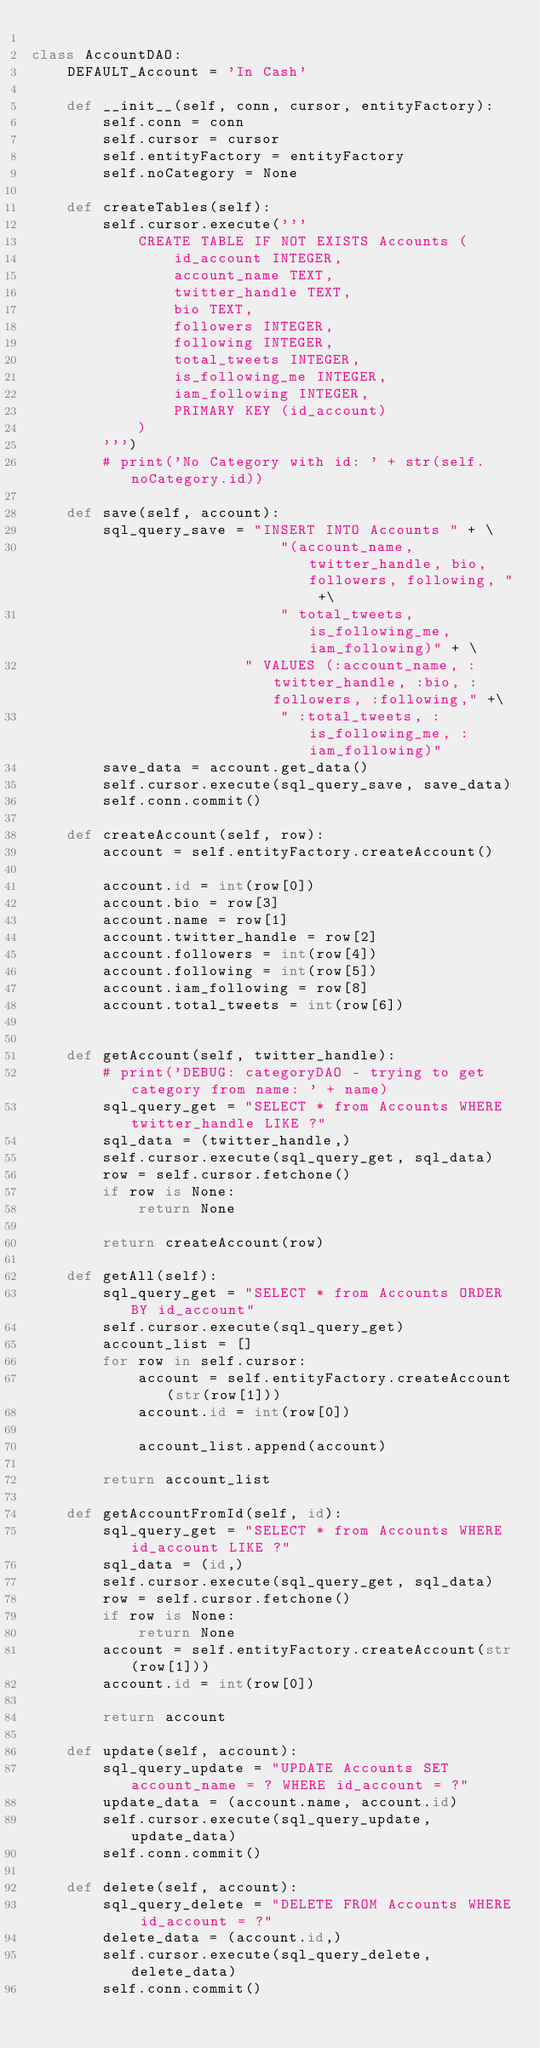<code> <loc_0><loc_0><loc_500><loc_500><_Python_>
class AccountDAO:
    DEFAULT_Account = 'In Cash'

    def __init__(self, conn, cursor, entityFactory):
        self.conn = conn
        self.cursor = cursor
        self.entityFactory = entityFactory
        self.noCategory = None

    def createTables(self):
        self.cursor.execute('''
            CREATE TABLE IF NOT EXISTS Accounts (
                id_account INTEGER,
                account_name TEXT,
                twitter_handle TEXT,
                bio TEXT,
                followers INTEGER,
                following INTEGER,
                total_tweets INTEGER,
                is_following_me INTEGER,
                iam_following INTEGER,
                PRIMARY KEY (id_account)
            )
        ''')
        # print('No Category with id: ' + str(self.noCategory.id))

    def save(self, account):
        sql_query_save = "INSERT INTO Accounts " + \
                            "(account_name, twitter_handle, bio, followers, following, " +\
                            " total_tweets, is_following_me, iam_following)" + \
                        " VALUES (:account_name, :twitter_handle, :bio, :followers, :following," +\
                            " :total_tweets, :is_following_me, :iam_following)"
        save_data = account.get_data()
        self.cursor.execute(sql_query_save, save_data)
        self.conn.commit()

    def createAccount(self, row):
        account = self.entityFactory.createAccount()

        account.id = int(row[0])
        account.bio = row[3]
        account.name = row[1]
        account.twitter_handle = row[2]
        account.followers = int(row[4])
        account.following = int(row[5])
        account.iam_following = row[8]
        account.total_tweets = int(row[6])


    def getAccount(self, twitter_handle):
        # print('DEBUG: categoryDAO - trying to get category from name: ' + name)
        sql_query_get = "SELECT * from Accounts WHERE twitter_handle LIKE ?"
        sql_data = (twitter_handle,)
        self.cursor.execute(sql_query_get, sql_data)
        row = self.cursor.fetchone()
        if row is None:
            return None
        
        return createAccount(row)

    def getAll(self):
        sql_query_get = "SELECT * from Accounts ORDER BY id_account"
        self.cursor.execute(sql_query_get)
        account_list = []
        for row in self.cursor:
            account = self.entityFactory.createAccount(str(row[1]))
            account.id = int(row[0])

            account_list.append(account)

        return account_list

    def getAccountFromId(self, id):
        sql_query_get = "SELECT * from Accounts WHERE id_account LIKE ?"
        sql_data = (id,)
        self.cursor.execute(sql_query_get, sql_data)
        row = self.cursor.fetchone()
        if row is None:
            return None
        account = self.entityFactory.createAccount(str(row[1]))
        account.id = int(row[0])

        return account

    def update(self, account):
        sql_query_update = "UPDATE Accounts SET account_name = ? WHERE id_account = ?"
        update_data = (account.name, account.id)
        self.cursor.execute(sql_query_update, update_data)
        self.conn.commit()

    def delete(self, account):
        sql_query_delete = "DELETE FROM Accounts WHERE id_account = ?"
        delete_data = (account.id,)
        self.cursor.execute(sql_query_delete, delete_data)
        self.conn.commit()

</code> 